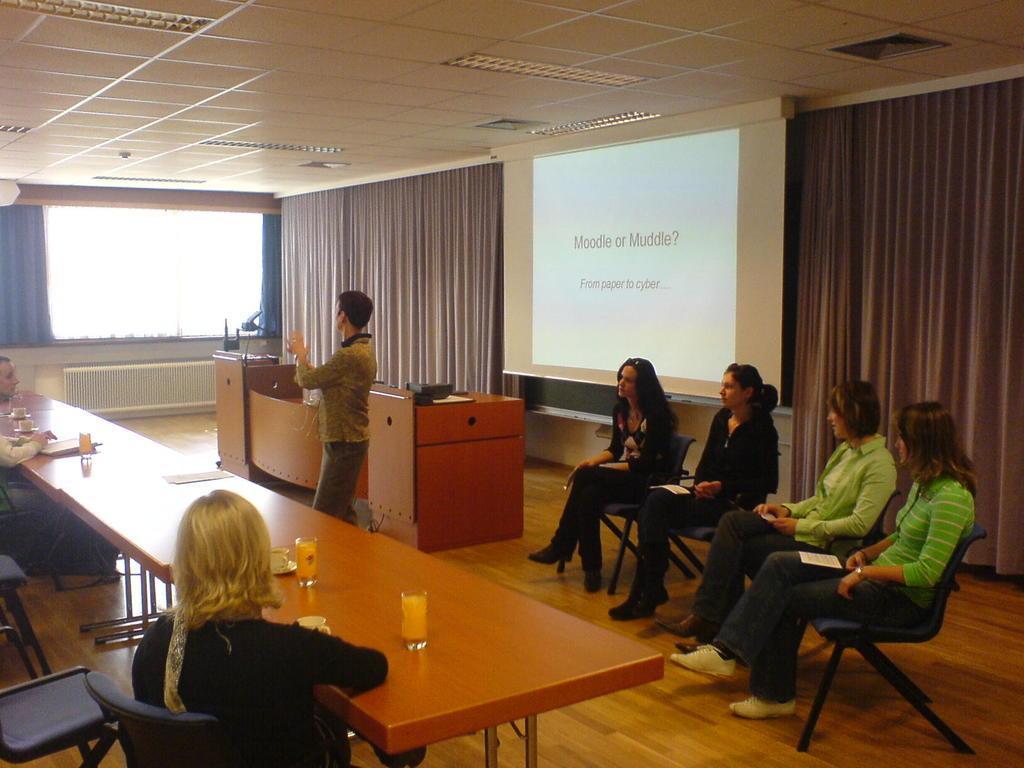Please provide a concise description of this image. In the middle of the image a person is standing. At the top of the image there is a roof. Top right side of the image there is a screen. Bottom right side of the image four women sitting on the chair. Bottom left side of the image there is a table, On the table there is a glass. Top left side of the image there is a curtain and there is a window. 